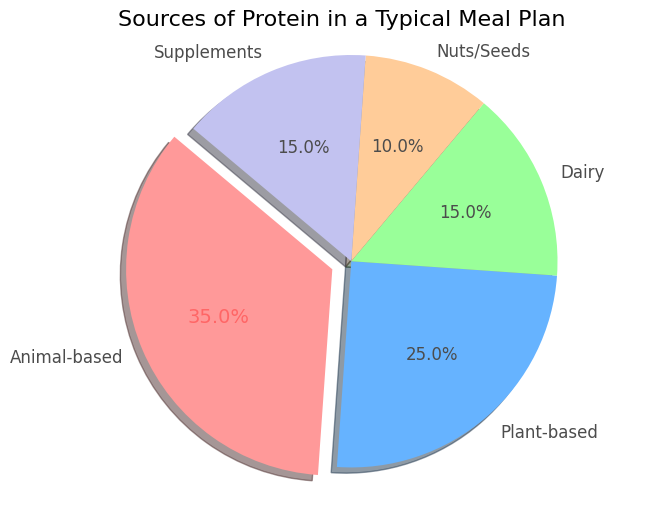What percentage of the protein sources come from animal-based and dairy combined? To find the combined percentage of animal-based and dairy proteins, add their individual percentages. Animal-based protein sources account for 35%, and dairy accounts for 15%. Therefore, the combined percentage is 35% + 15% = 50%.
Answer: 50% Which protein source category contributes the most to the meal plan? The chart shows the protein sources and their respective percentages. The animal-based category has the highest value at 35%.
Answer: Animal-based How much more protein comes from supplements than from nuts/seeds? The percentage of protein from supplements is 15%, and from nuts/seeds, it is 10%. The difference is calculated as 15% - 10% = 5%.
Answer: 5% What are the two least contributing sources of protein in the meal plan, and what is their total percentage? Identify the categories with the smallest percentages: nuts/seeds (10%) and dairy (15%). Their total is 10% + 15% = 25%.
Answer: Dairy and Nuts/Seeds; 25% Are plant-based proteins more prevalent than dairy proteins in the meal plan? Compare the percentages of plant-based (25%) and dairy (15%) proteins. Since 25% is greater than 15%, plant-based proteins are indeed more prevalent.
Answer: Yes What is the average percentage of the non-animal based protein sources (Plant-based, Dairy, Nuts/Seeds, Supplements)? To find the average, add the percentages of plant-based (25%), dairy (15%), nuts/seeds (10%), and supplements (15%), then divide by 4. The calculation is (25% + 15% + 10% + 15%) / 4 = 65% / 4 = 16.25%.
Answer: 16.25% Which segment in the pie chart is highlighted (exploded)? The visual aspect of the pie chart shows the 'exploded' (highlighted) segment, which in this case is animal-based proteins.
Answer: Animal-based What percentage of protein comes from non-plant-based sources? Non-plant-based sources include Animal-based (35%), Dairy (15%), Nuts/Seeds (10%), and Supplements (15%). The total percentage is calculated by adding these values: 35% + 15% + 10% + 15% = 75%.
Answer: 75% By how much does the combined percentage of animal-based and plant-based proteins exceed that of the remaining sources? Calculate the combined percentage of animal-based (35%) and plant-based (25%) proteins: 35% + 25% = 60%. The remaining sources (Dairy, Nuts/Seeds, Supplements) sum to 15% + 10% + 15% = 40%. The excess is calculated as 60% - 40% = 20%.
Answer: 20% 